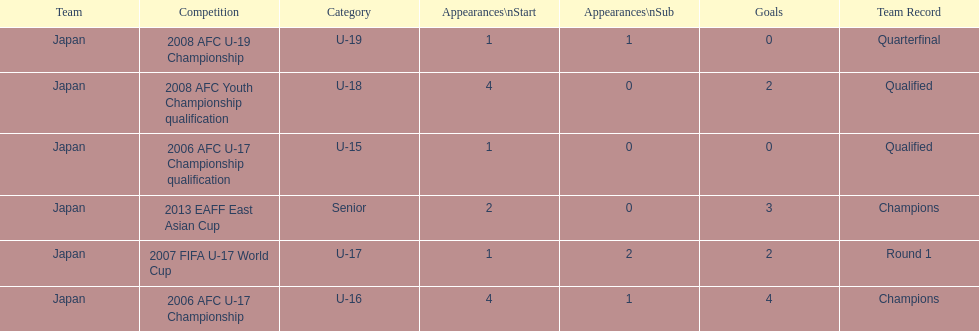Parse the table in full. {'header': ['Team', 'Competition', 'Category', 'Appearances\\nStart', 'Appearances\\nSub', 'Goals', 'Team Record'], 'rows': [['Japan', '2008 AFC U-19 Championship', 'U-19', '1', '1', '0', 'Quarterfinal'], ['Japan', '2008 AFC Youth Championship qualification', 'U-18', '4', '0', '2', 'Qualified'], ['Japan', '2006 AFC U-17 Championship qualification', 'U-15', '1', '0', '0', 'Qualified'], ['Japan', '2013 EAFF East Asian Cup', 'Senior', '2', '0', '3', 'Champions'], ['Japan', '2007 FIFA U-17 World Cup', 'U-17', '1', '2', '2', 'Round 1'], ['Japan', '2006 AFC U-17 Championship', 'U-16', '4', '1', '4', 'Champions']]} In which two competitions did japan lack goals? 2006 AFC U-17 Championship qualification, 2008 AFC U-19 Championship. 